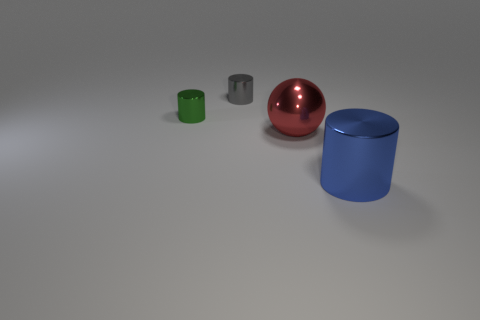How big is the ball?
Keep it short and to the point. Large. Are there more small blue metal cylinders than tiny shiny objects?
Make the answer very short. No. The large metal thing that is on the left side of the metallic object that is to the right of the large metal object behind the blue metallic object is what color?
Make the answer very short. Red. There is a big metal object behind the big metallic cylinder; is its shape the same as the gray shiny object?
Ensure brevity in your answer.  No. What color is the object that is the same size as the sphere?
Offer a very short reply. Blue. How many cylinders are there?
Your answer should be compact. 3. Do the thing that is on the right side of the metallic sphere and the gray cylinder have the same material?
Your response must be concise. Yes. There is a cylinder that is behind the large metallic cylinder and to the right of the green shiny cylinder; what is it made of?
Provide a short and direct response. Metal. There is a big thing that is behind the metal cylinder in front of the green thing; what is its material?
Ensure brevity in your answer.  Metal. What is the size of the object that is behind the thing that is on the left side of the cylinder behind the small green object?
Offer a terse response. Small. 